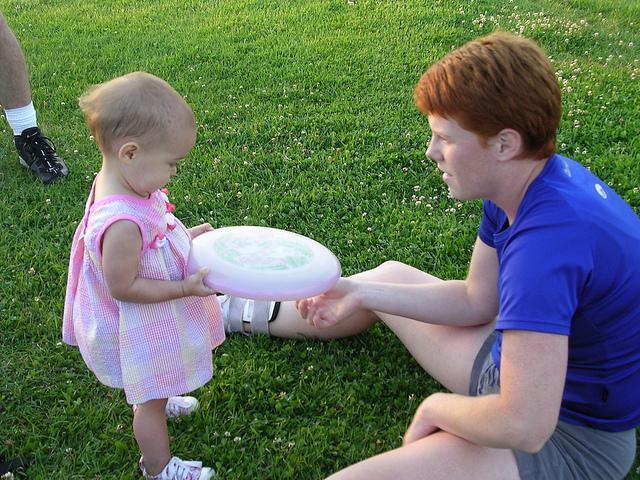How many people can be seen?
Give a very brief answer. 3. 